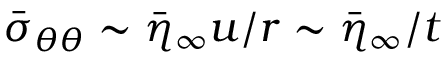<formula> <loc_0><loc_0><loc_500><loc_500>\bar { \sigma } _ { \theta \theta } \sim \bar { \eta } _ { \infty } u / r \sim \bar { \eta } _ { \infty } / t</formula> 